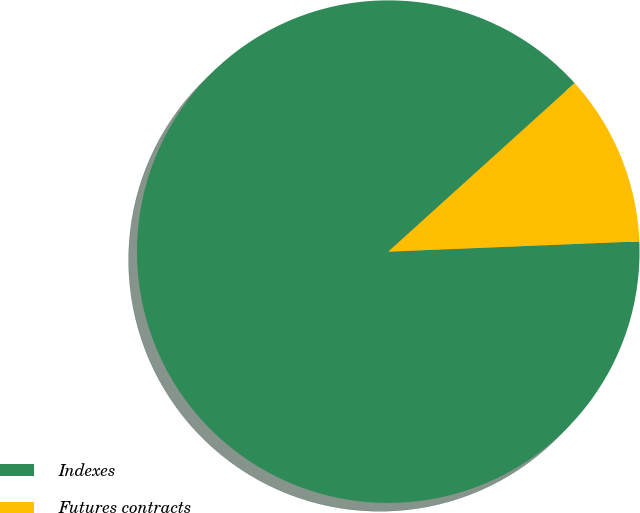<chart> <loc_0><loc_0><loc_500><loc_500><pie_chart><fcel>Indexes<fcel>Futures contracts<nl><fcel>88.95%<fcel>11.05%<nl></chart> 